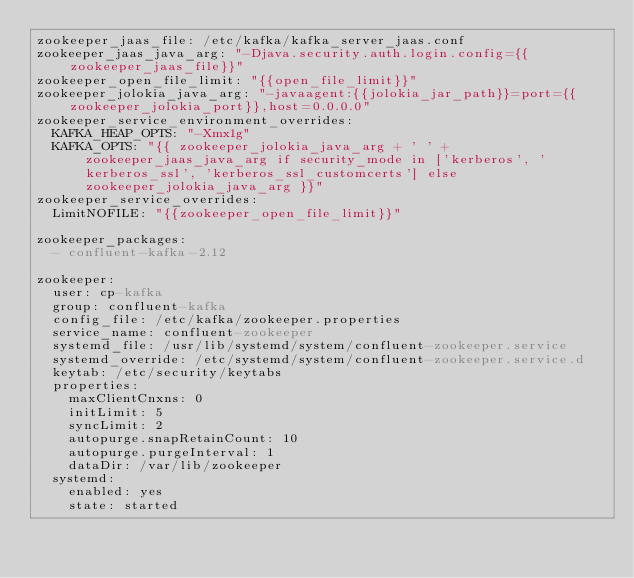<code> <loc_0><loc_0><loc_500><loc_500><_YAML_>zookeeper_jaas_file: /etc/kafka/kafka_server_jaas.conf
zookeeper_jaas_java_arg: "-Djava.security.auth.login.config={{zookeeper_jaas_file}}"
zookeeper_open_file_limit: "{{open_file_limit}}"
zookeeper_jolokia_java_arg: "-javaagent:{{jolokia_jar_path}}=port={{zookeeper_jolokia_port}},host=0.0.0.0"
zookeeper_service_environment_overrides:
  KAFKA_HEAP_OPTS: "-Xmx1g"
  KAFKA_OPTS: "{{ zookeeper_jolokia_java_arg + ' ' + zookeeper_jaas_java_arg if security_mode in ['kerberos', 'kerberos_ssl', 'kerberos_ssl_customcerts'] else zookeeper_jolokia_java_arg }}"
zookeeper_service_overrides:
  LimitNOFILE: "{{zookeeper_open_file_limit}}"

zookeeper_packages:
  - confluent-kafka-2.12

zookeeper:
  user: cp-kafka
  group: confluent-kafka
  config_file: /etc/kafka/zookeeper.properties
  service_name: confluent-zookeeper
  systemd_file: /usr/lib/systemd/system/confluent-zookeeper.service
  systemd_override: /etc/systemd/system/confluent-zookeeper.service.d
  keytab: /etc/security/keytabs
  properties:
    maxClientCnxns: 0
    initLimit: 5
    syncLimit: 2
    autopurge.snapRetainCount: 10
    autopurge.purgeInterval: 1
    dataDir: /var/lib/zookeeper
  systemd:
    enabled: yes
    state: started
</code> 